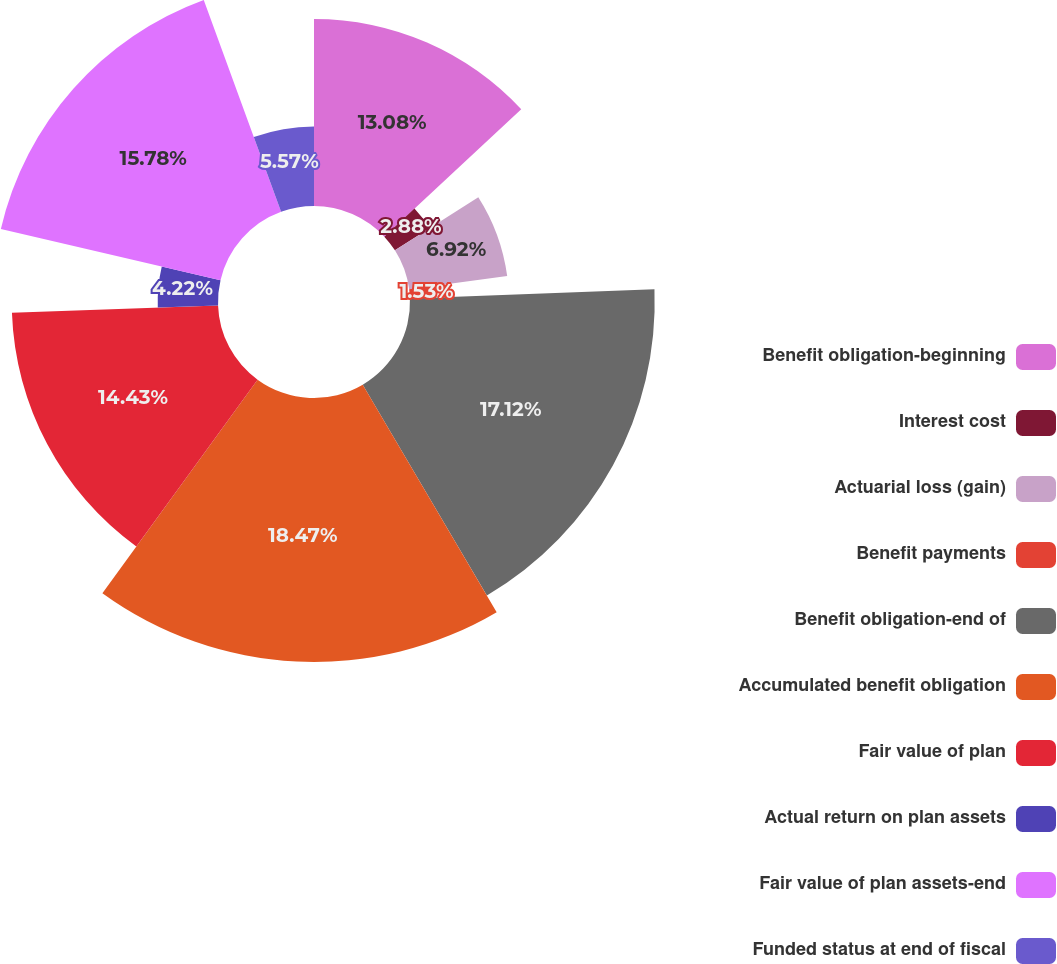<chart> <loc_0><loc_0><loc_500><loc_500><pie_chart><fcel>Benefit obligation-beginning<fcel>Interest cost<fcel>Actuarial loss (gain)<fcel>Benefit payments<fcel>Benefit obligation-end of<fcel>Accumulated benefit obligation<fcel>Fair value of plan<fcel>Actual return on plan assets<fcel>Fair value of plan assets-end<fcel>Funded status at end of fiscal<nl><fcel>13.08%<fcel>2.88%<fcel>6.92%<fcel>1.53%<fcel>17.12%<fcel>18.47%<fcel>14.43%<fcel>4.22%<fcel>15.78%<fcel>5.57%<nl></chart> 